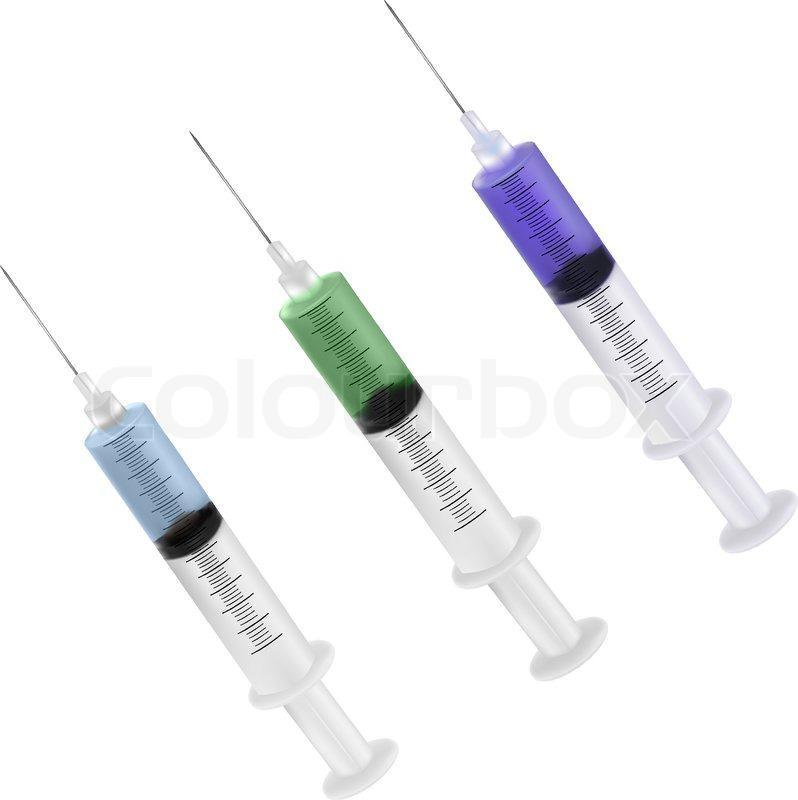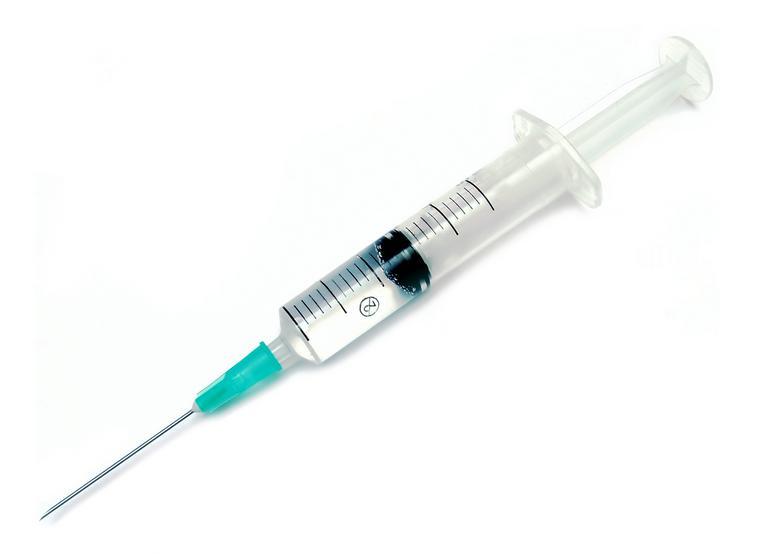The first image is the image on the left, the second image is the image on the right. For the images shown, is this caption "Each image shows exactly one syringe, displayed at an angle." true? Answer yes or no. No. The first image is the image on the left, the second image is the image on the right. Given the left and right images, does the statement "Each image shows only a single syringe." hold true? Answer yes or no. No. 